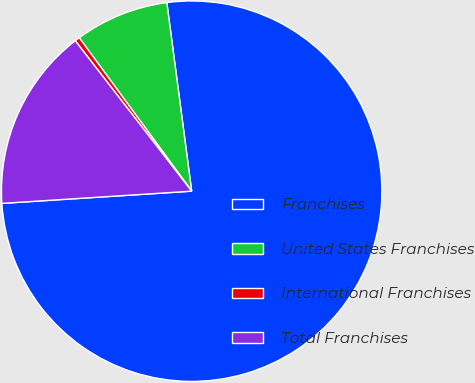<chart> <loc_0><loc_0><loc_500><loc_500><pie_chart><fcel>Franchises<fcel>United States Franchises<fcel>International Franchises<fcel>Total Franchises<nl><fcel>76.06%<fcel>7.98%<fcel>0.42%<fcel>15.54%<nl></chart> 